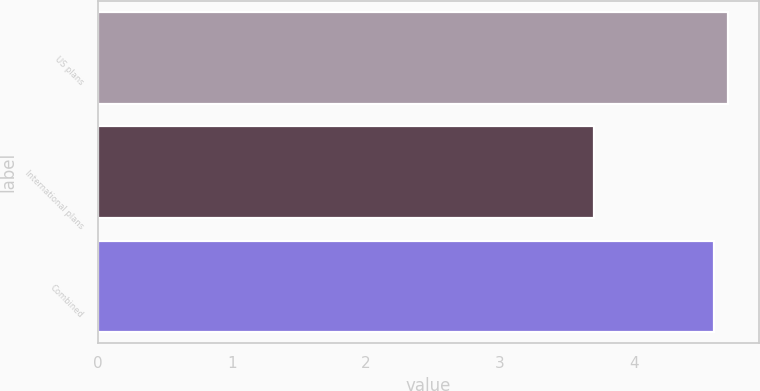Convert chart. <chart><loc_0><loc_0><loc_500><loc_500><bar_chart><fcel>US plans<fcel>International plans<fcel>Combined<nl><fcel>4.7<fcel>3.7<fcel>4.6<nl></chart> 